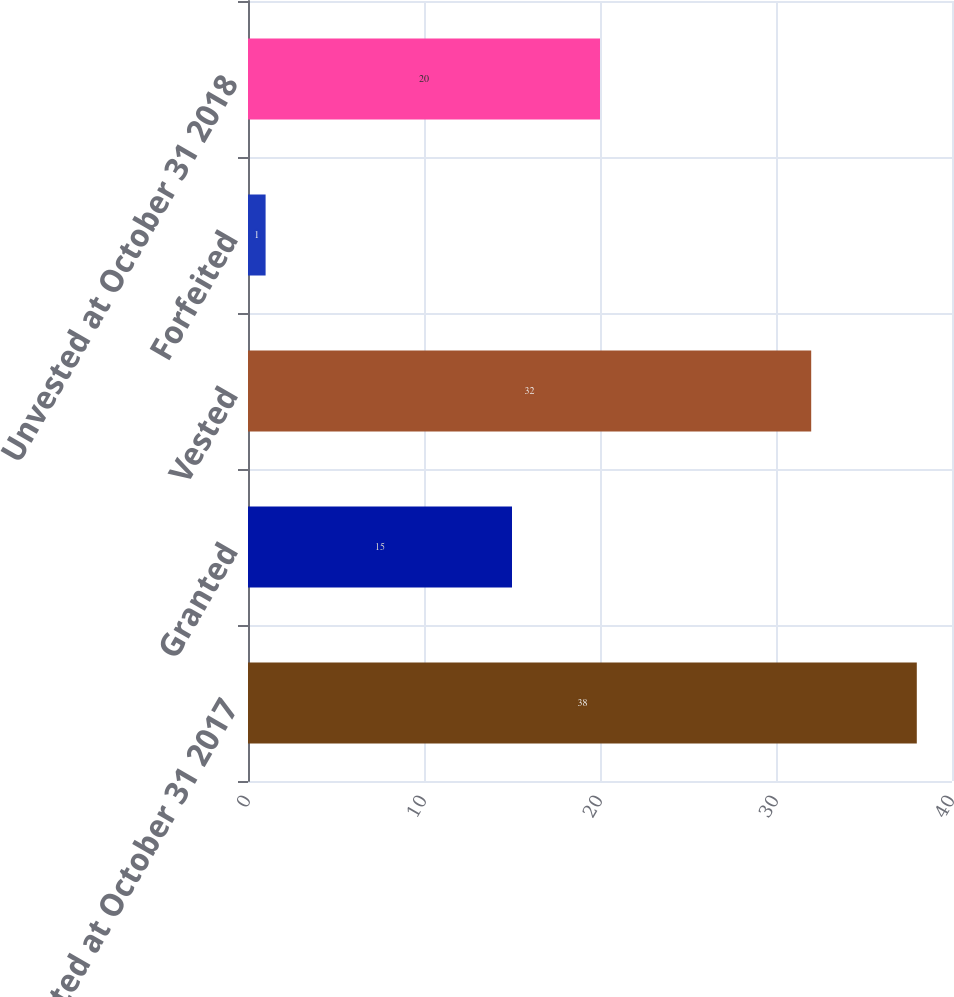<chart> <loc_0><loc_0><loc_500><loc_500><bar_chart><fcel>Unvested at October 31 2017<fcel>Granted<fcel>Vested<fcel>Forfeited<fcel>Unvested at October 31 2018<nl><fcel>38<fcel>15<fcel>32<fcel>1<fcel>20<nl></chart> 